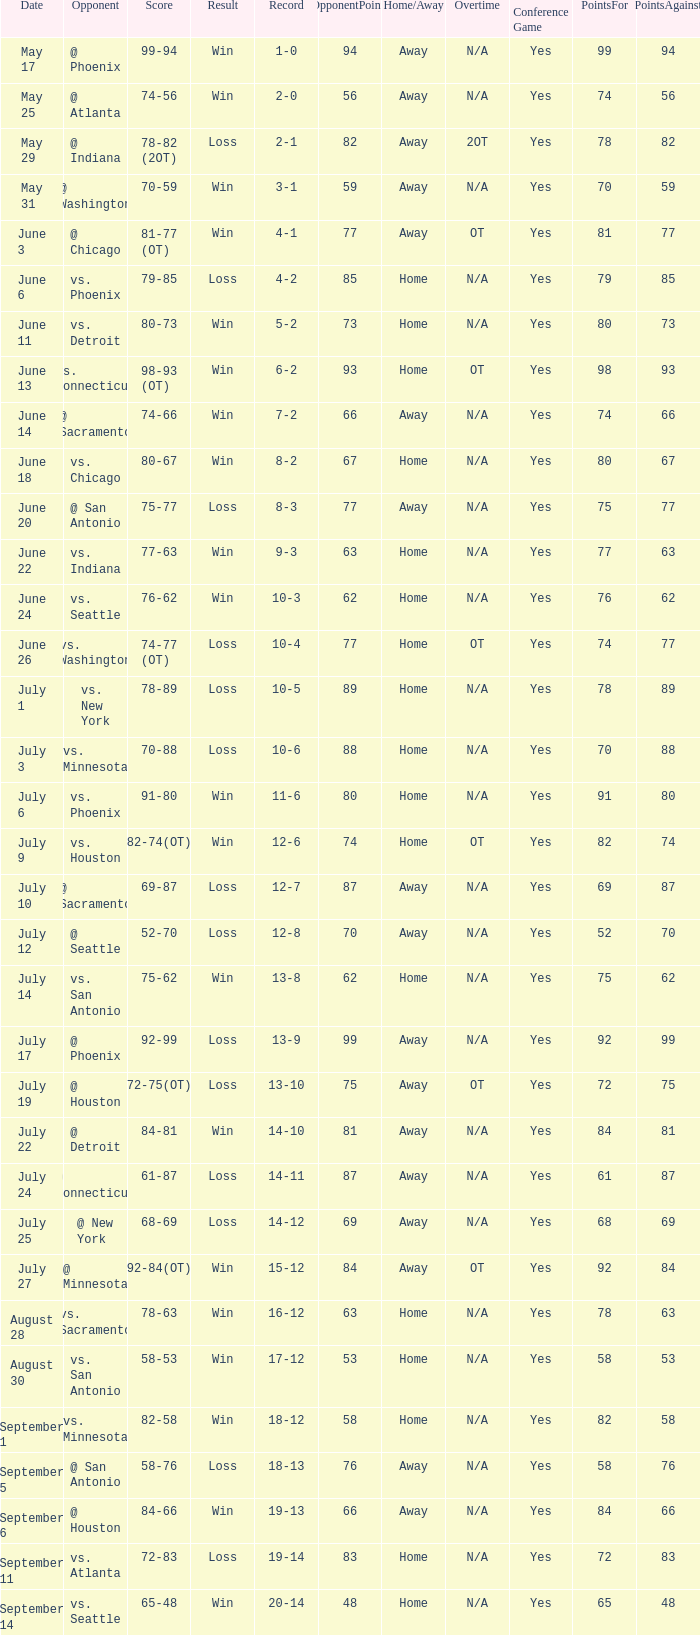What is the Record of the game with a Score of 65-48? 20-14. 